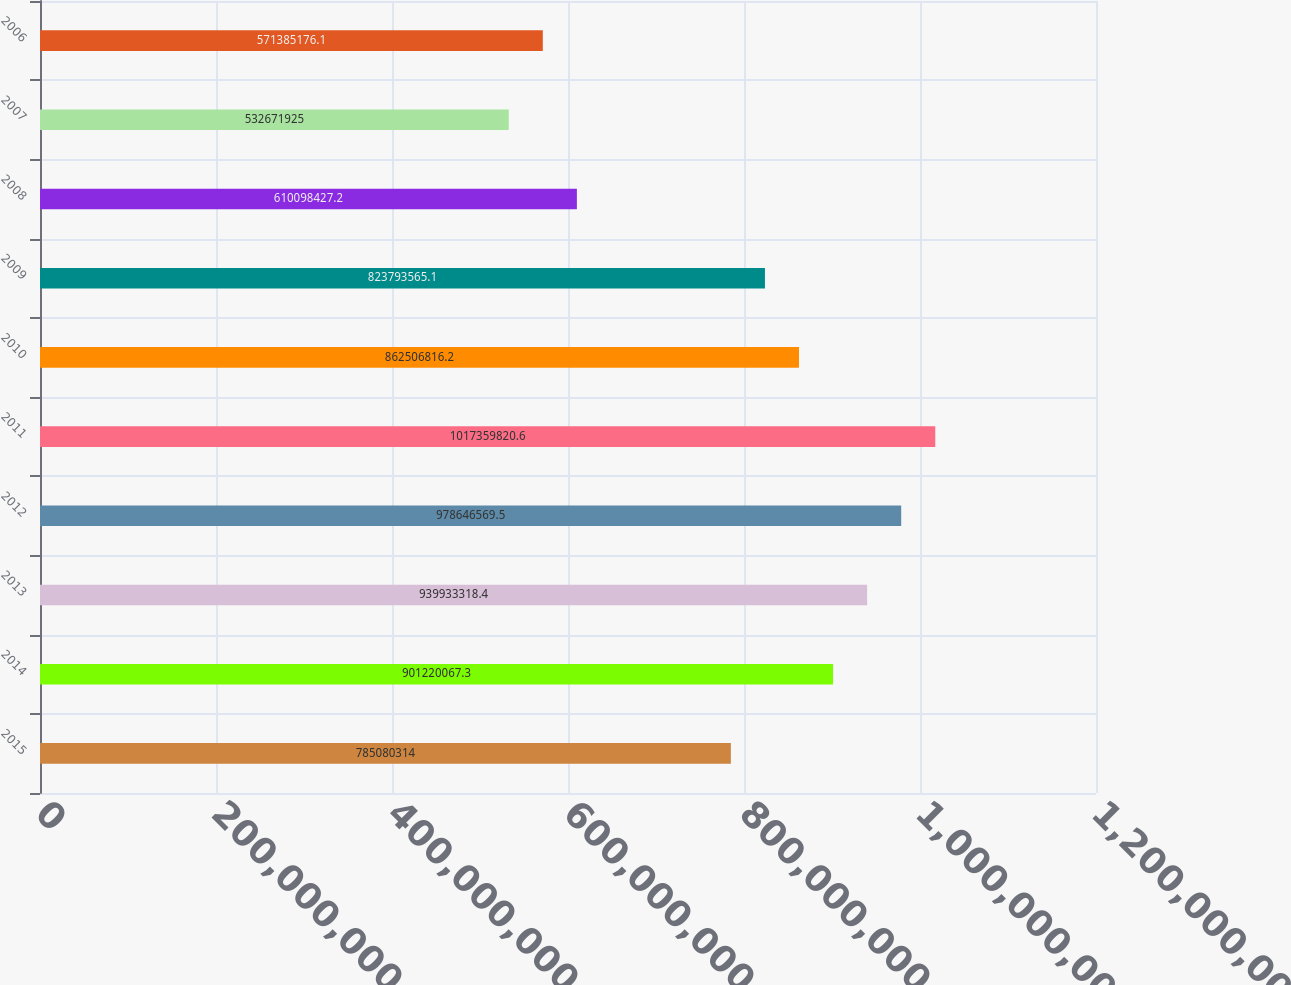Convert chart to OTSL. <chart><loc_0><loc_0><loc_500><loc_500><bar_chart><fcel>2015<fcel>2014<fcel>2013<fcel>2012<fcel>2011<fcel>2010<fcel>2009<fcel>2008<fcel>2007<fcel>2006<nl><fcel>7.8508e+08<fcel>9.0122e+08<fcel>9.39933e+08<fcel>9.78647e+08<fcel>1.01736e+09<fcel>8.62507e+08<fcel>8.23794e+08<fcel>6.10098e+08<fcel>5.32672e+08<fcel>5.71385e+08<nl></chart> 